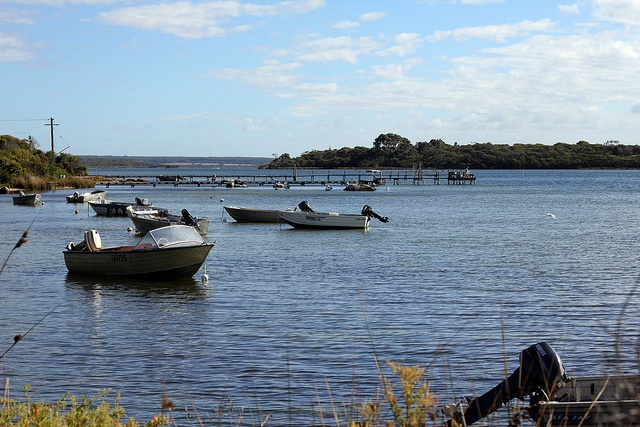Describe the objects in this image and their specific colors. I can see boat in lavender, black, darkgray, gray, and lightgray tones, boat in lavender, black, and gray tones, boat in lavender, gray, black, darkgray, and purple tones, boat in lavender, black, gray, darkgray, and white tones, and boat in lavender, black, gray, darkgray, and lightblue tones in this image. 